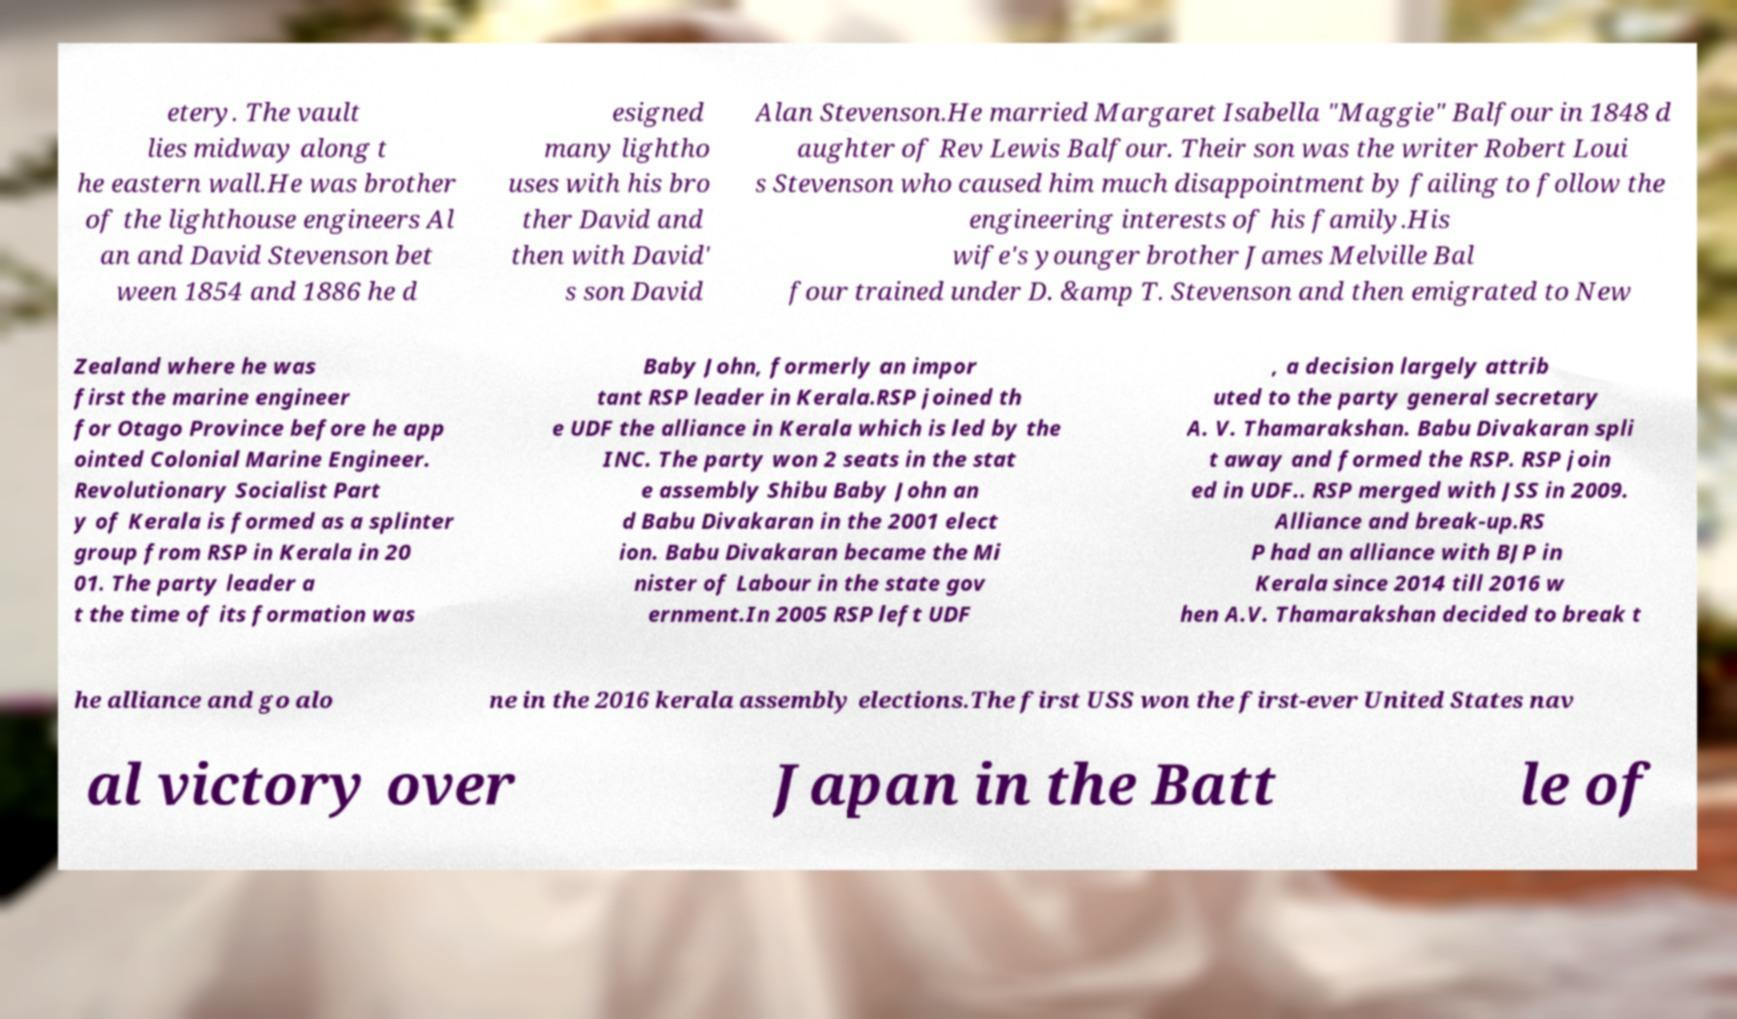Can you accurately transcribe the text from the provided image for me? etery. The vault lies midway along t he eastern wall.He was brother of the lighthouse engineers Al an and David Stevenson bet ween 1854 and 1886 he d esigned many lightho uses with his bro ther David and then with David' s son David Alan Stevenson.He married Margaret Isabella "Maggie" Balfour in 1848 d aughter of Rev Lewis Balfour. Their son was the writer Robert Loui s Stevenson who caused him much disappointment by failing to follow the engineering interests of his family.His wife's younger brother James Melville Bal four trained under D. &amp T. Stevenson and then emigrated to New Zealand where he was first the marine engineer for Otago Province before he app ointed Colonial Marine Engineer. Revolutionary Socialist Part y of Kerala is formed as a splinter group from RSP in Kerala in 20 01. The party leader a t the time of its formation was Baby John, formerly an impor tant RSP leader in Kerala.RSP joined th e UDF the alliance in Kerala which is led by the INC. The party won 2 seats in the stat e assembly Shibu Baby John an d Babu Divakaran in the 2001 elect ion. Babu Divakaran became the Mi nister of Labour in the state gov ernment.In 2005 RSP left UDF , a decision largely attrib uted to the party general secretary A. V. Thamarakshan. Babu Divakaran spli t away and formed the RSP. RSP join ed in UDF.. RSP merged with JSS in 2009. Alliance and break-up.RS P had an alliance with BJP in Kerala since 2014 till 2016 w hen A.V. Thamarakshan decided to break t he alliance and go alo ne in the 2016 kerala assembly elections.The first USS won the first-ever United States nav al victory over Japan in the Batt le of 